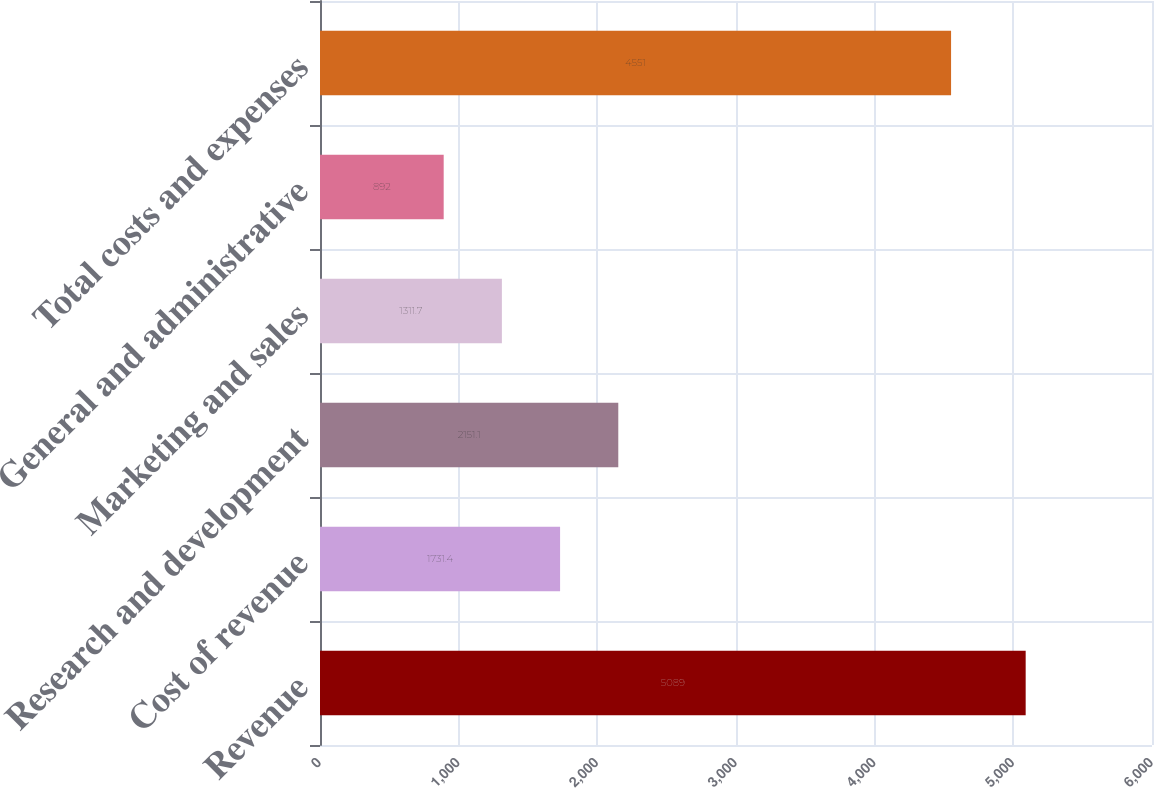<chart> <loc_0><loc_0><loc_500><loc_500><bar_chart><fcel>Revenue<fcel>Cost of revenue<fcel>Research and development<fcel>Marketing and sales<fcel>General and administrative<fcel>Total costs and expenses<nl><fcel>5089<fcel>1731.4<fcel>2151.1<fcel>1311.7<fcel>892<fcel>4551<nl></chart> 